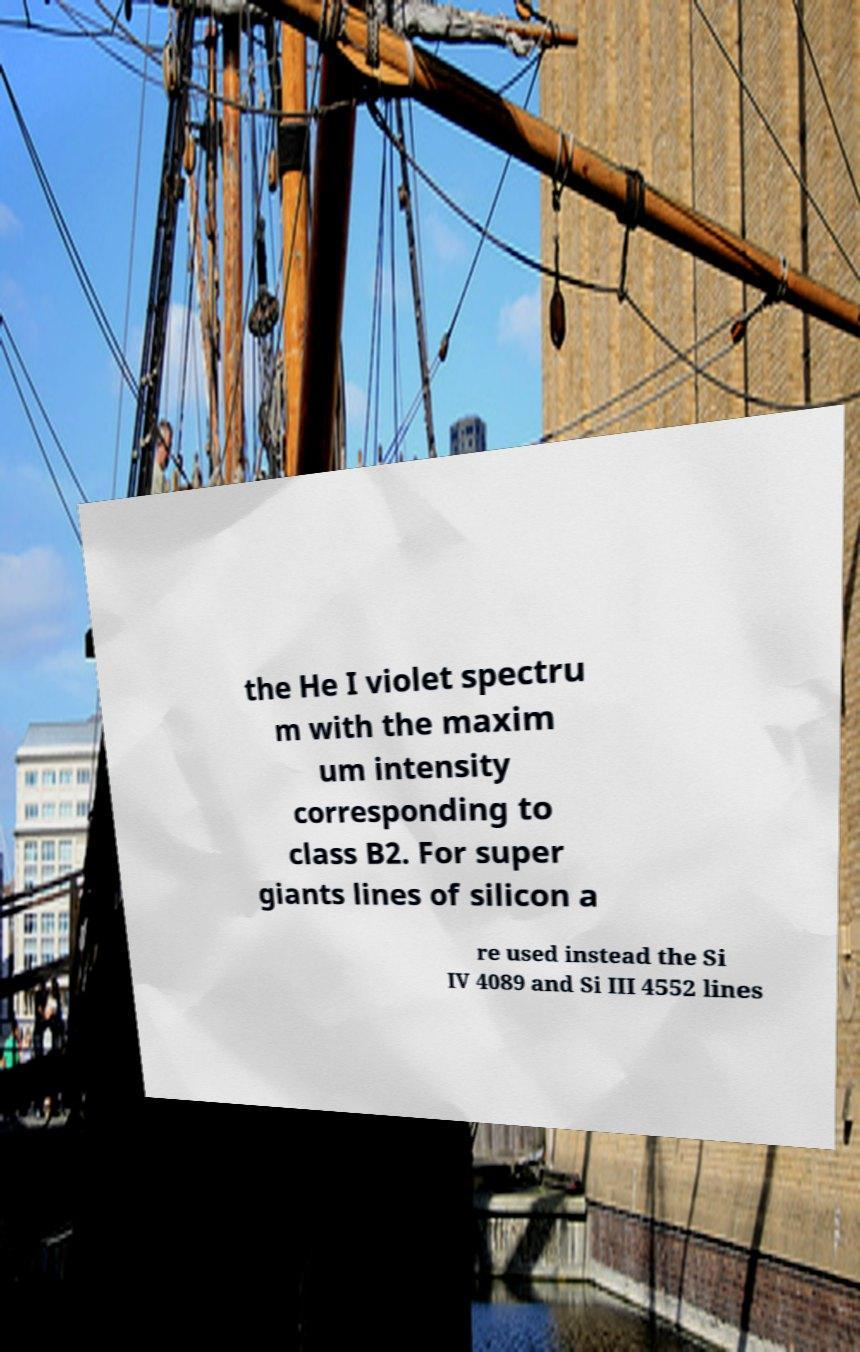I need the written content from this picture converted into text. Can you do that? the He I violet spectru m with the maxim um intensity corresponding to class B2. For super giants lines of silicon a re used instead the Si IV 4089 and Si III 4552 lines 